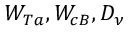<formula> <loc_0><loc_0><loc_500><loc_500>W _ { T a } , W _ { c B } , { D _ { \nu } }</formula> 